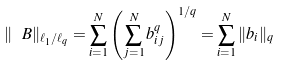Convert formula to latex. <formula><loc_0><loc_0><loc_500><loc_500>\| \ B \| _ { \ell _ { 1 } / \ell _ { q } } = \sum _ { i = 1 } ^ { N } \left ( \sum _ { j = 1 } ^ { N } b _ { i j } ^ { q } \right ) ^ { 1 / q } = \sum _ { i = 1 } ^ { N } \| b _ { i } \| _ { q }</formula> 